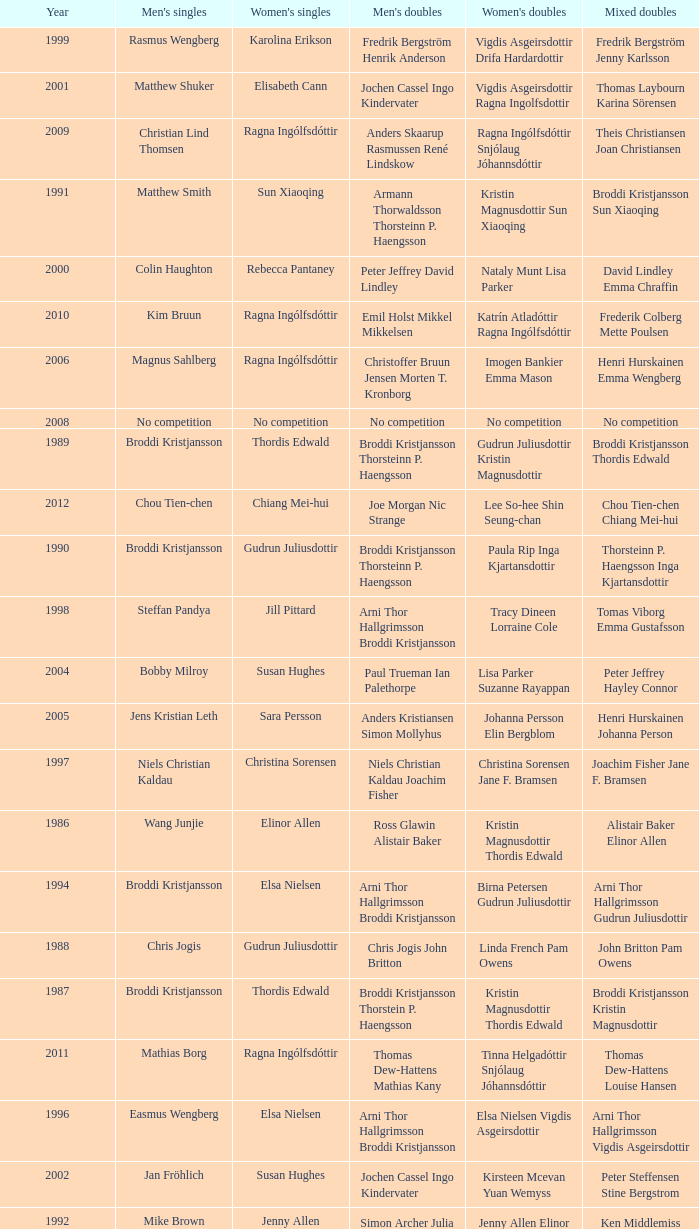In what mixed doubles did Niels Christian Kaldau play in men's singles? Joachim Fisher Jane F. Bramsen. 